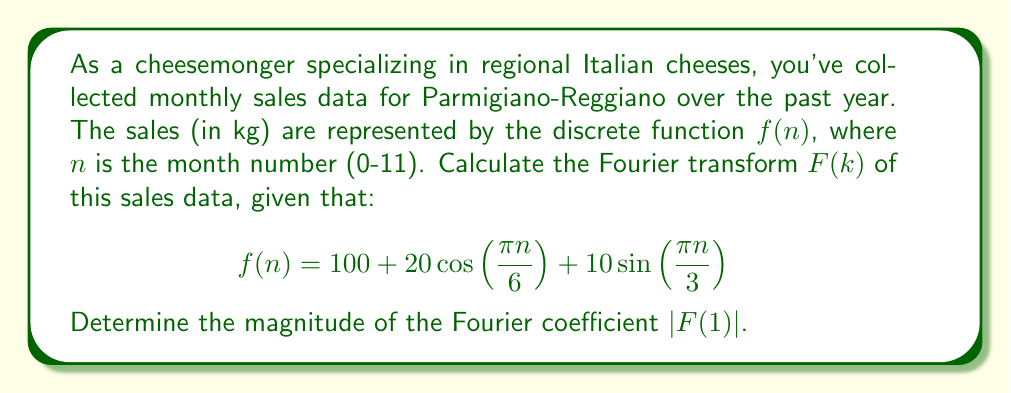Can you solve this math problem? To solve this problem, we'll follow these steps:

1) The Discrete Fourier Transform (DFT) for a sequence of N points is given by:

   $$F(k) = \sum_{n=0}^{N-1} f(n) e^{-i2\pi kn/N}$$

   Here, N = 12 (12 months of data).

2) We need to calculate $F(1)$, so let's substitute k = 1:

   $$F(1) = \sum_{n=0}^{11} f(n) e^{-i2\pi n/12}$$

3) Substitute the given function for f(n):

   $$F(1) = \sum_{n=0}^{11} (100 + 20\cos(\frac{\pi n}{6}) + 10\sin(\frac{\pi n}{3})) e^{-i2\pi n/12}$$

4) This can be split into three sums:

   $$F(1) = 100\sum_{n=0}^{11} e^{-i2\pi n/12} + 20\sum_{n=0}^{11} \cos(\frac{\pi n}{6})e^{-i2\pi n/12} + 10\sum_{n=0}^{11} \sin(\frac{\pi n}{3})e^{-i2\pi n/12}$$

5) The first sum is a geometric series that sums to zero for k ≠ 0.

6) For the second sum, we can use the identity $\cos A = \frac{e^{iA} + e^{-iA}}{2}$:

   $$20\sum_{n=0}^{11} \cos(\frac{\pi n}{6})e^{-i2\pi n/12} = 10\sum_{n=0}^{11} (e^{i\pi n/6} + e^{-i\pi n/6})e^{-i2\pi n/12}$$
   $$= 10\sum_{n=0}^{11} (e^{-i\pi n/4} + e^{-i5\pi n/12}) = 10(12) = 120$$

7) For the third sum, we can use $\sin A = \frac{e^{iA} - e^{-iA}}{2i}$:

   $$10\sum_{n=0}^{11} \sin(\frac{\pi n}{3})e^{-i2\pi n/12} = \frac{10}{2i}\sum_{n=0}^{11} (e^{i\pi n/3} - e^{-i\pi n/3})e^{-i2\pi n/12}$$
   $$= \frac{10}{2i}\sum_{n=0}^{11} (e^{-i\pi n/6} - e^{-i5\pi n/6}) = \frac{10}{2i}(12i) = 60$$

8) Therefore, $F(1) = 120 + 60 = 180$

9) The magnitude of $F(1)$ is its absolute value: $|F(1)| = |180| = 180$
Answer: $|F(1)| = 180$ 